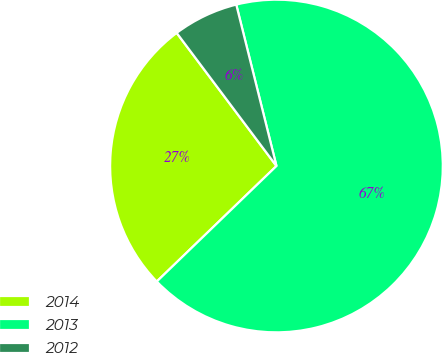Convert chart. <chart><loc_0><loc_0><loc_500><loc_500><pie_chart><fcel>2014<fcel>2013<fcel>2012<nl><fcel>26.98%<fcel>66.67%<fcel>6.35%<nl></chart> 